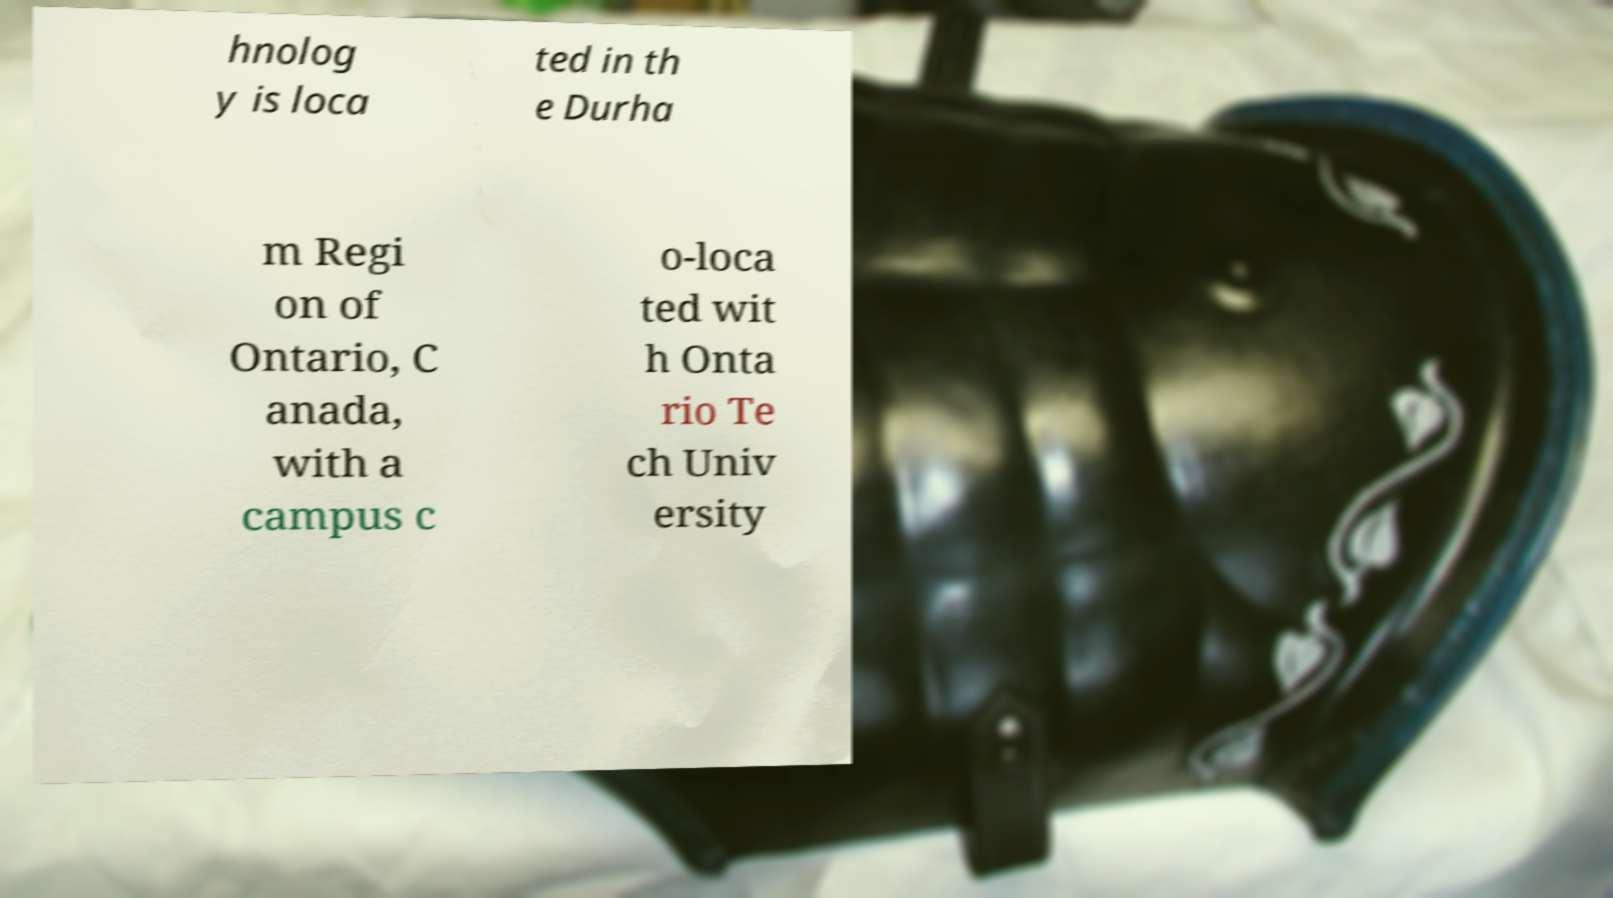Can you accurately transcribe the text from the provided image for me? hnolog y is loca ted in th e Durha m Regi on of Ontario, C anada, with a campus c o-loca ted wit h Onta rio Te ch Univ ersity 